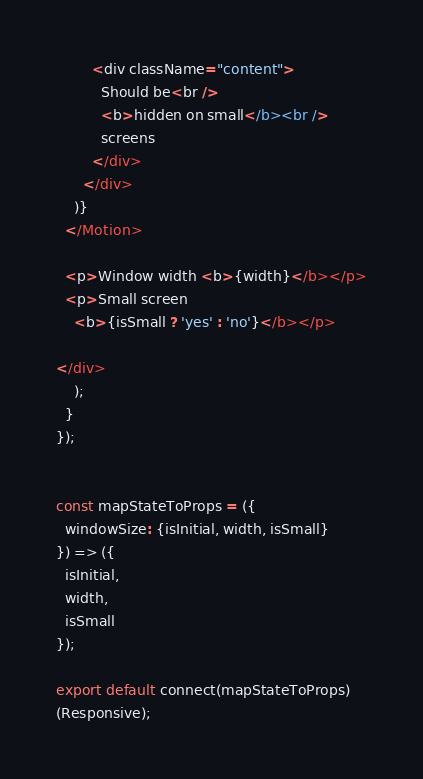<code> <loc_0><loc_0><loc_500><loc_500><_JavaScript_>
        <div className="content">
          Should be<br />
          <b>hidden on small</b><br />
          screens
        </div>
      </div>
    )}
  </Motion>

  <p>Window width <b>{width}</b></p>
  <p>Small screen
    <b>{isSmall ? 'yes' : 'no'}</b></p>

</div>
    );
  }
});


const mapStateToProps = ({
  windowSize: {isInitial, width, isSmall}
}) => ({
  isInitial,
  width,
  isSmall
});

export default connect(mapStateToProps)
(Responsive);
</code> 